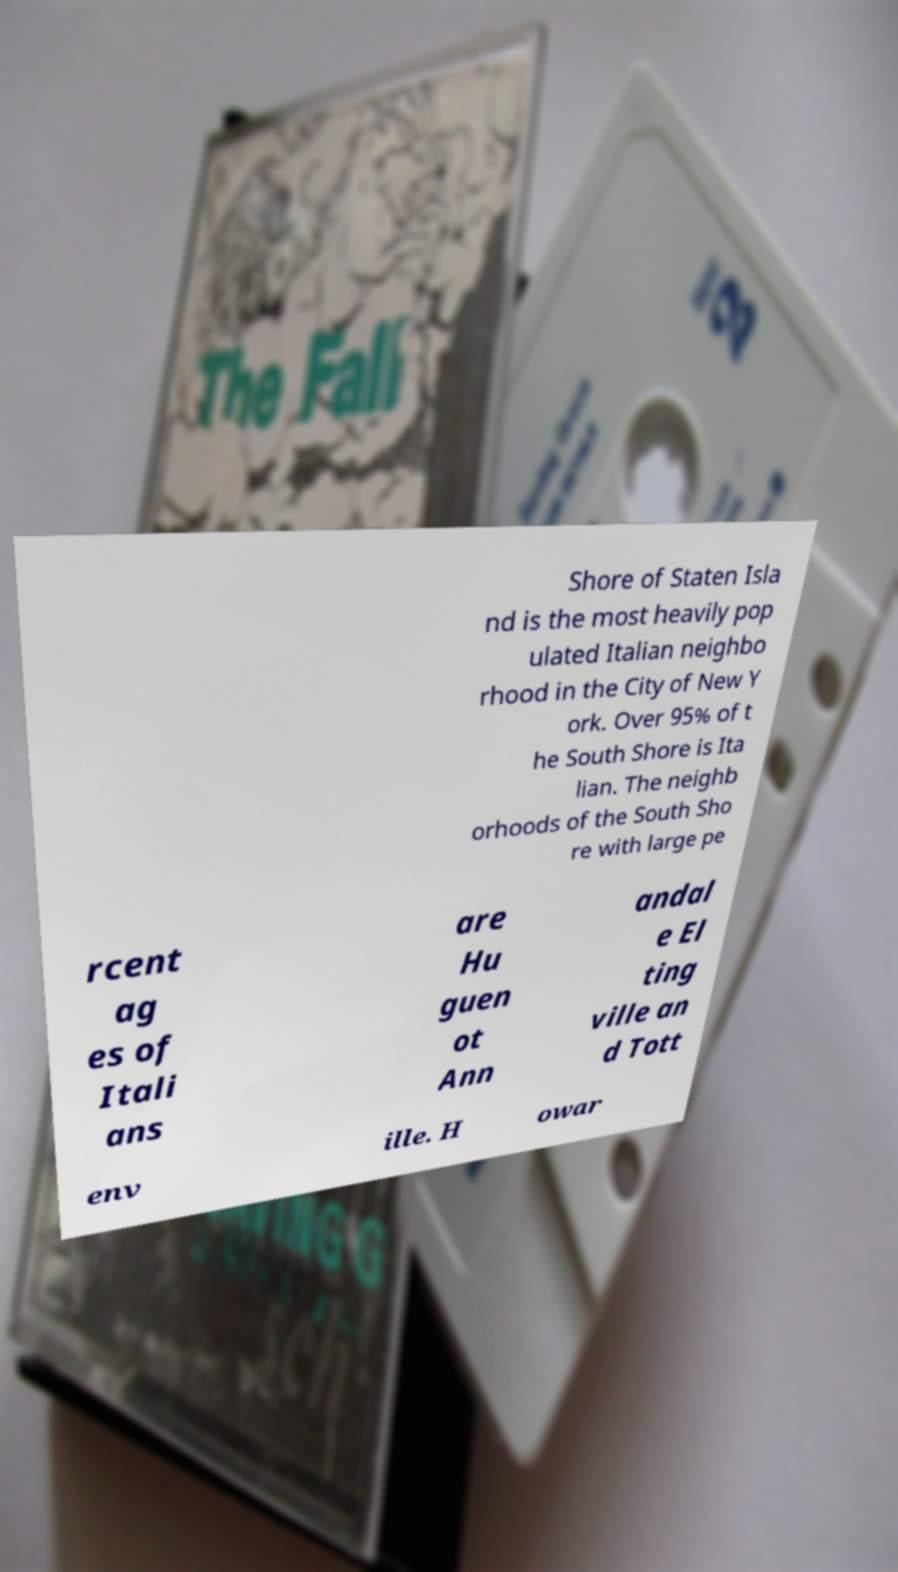For documentation purposes, I need the text within this image transcribed. Could you provide that? Shore of Staten Isla nd is the most heavily pop ulated Italian neighbo rhood in the City of New Y ork. Over 95% of t he South Shore is Ita lian. The neighb orhoods of the South Sho re with large pe rcent ag es of Itali ans are Hu guen ot Ann andal e El ting ville an d Tott env ille. H owar 